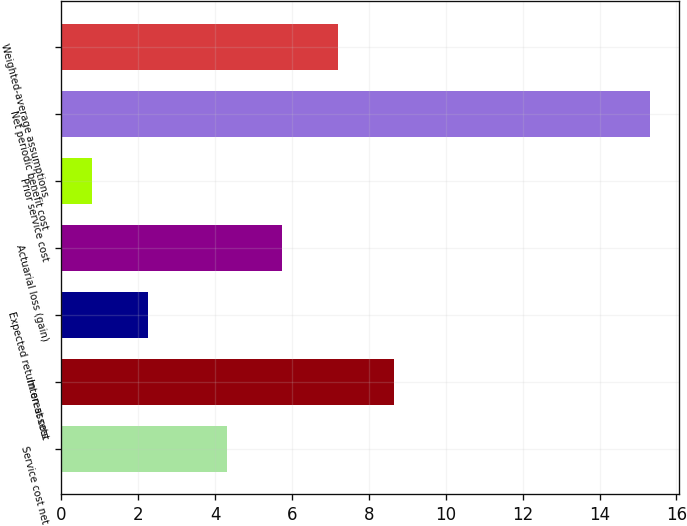<chart> <loc_0><loc_0><loc_500><loc_500><bar_chart><fcel>Service cost net<fcel>Interest cost<fcel>Expected return on assets<fcel>Actuarial loss (gain)<fcel>Prior service cost<fcel>Net periodic benefit cost<fcel>Weighted-average assumptions<nl><fcel>4.3<fcel>8.65<fcel>2.25<fcel>5.75<fcel>0.8<fcel>15.3<fcel>7.2<nl></chart> 